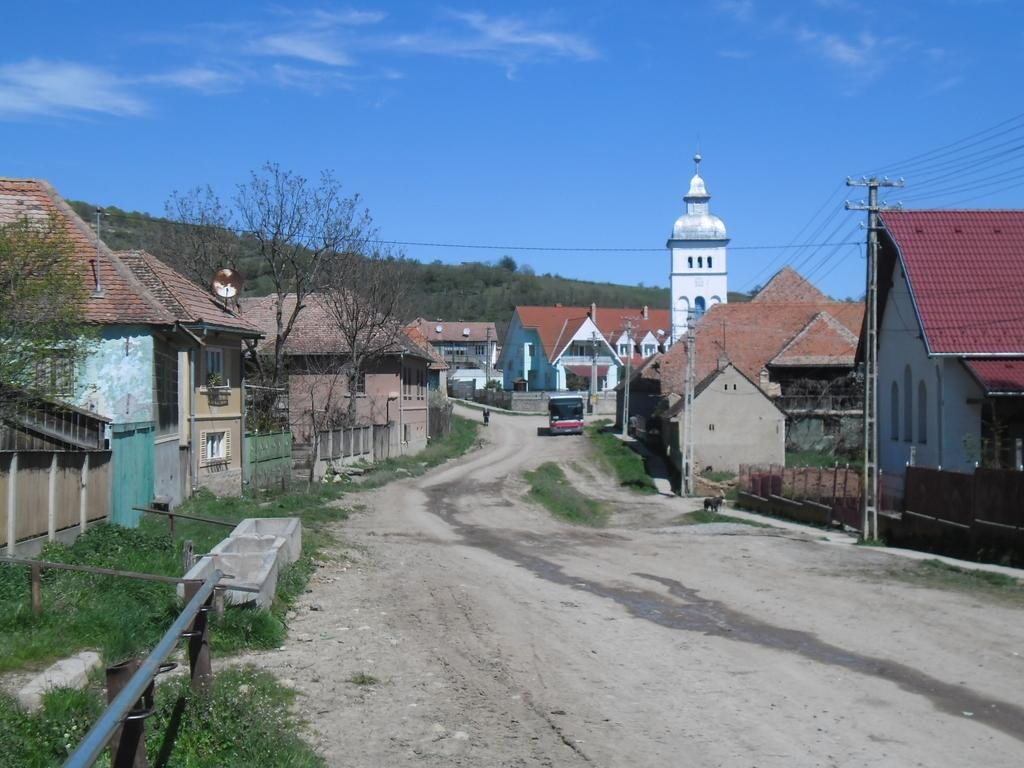What colors are the houses in the image? The houses in the image are in brown, green, and cream colors. What type of vegetation can be seen in the image? There is grass and trees in green color in the image. What structures are present in the image besides the houses? There are electric poles in the image. What is the color of the sky in the image? The sky is in white and blue color in the image. What type of collar can be seen on the dog in the image? There is no dog or collar present in the image. What type of hall can be seen in the image? There is no hall present in the image. 